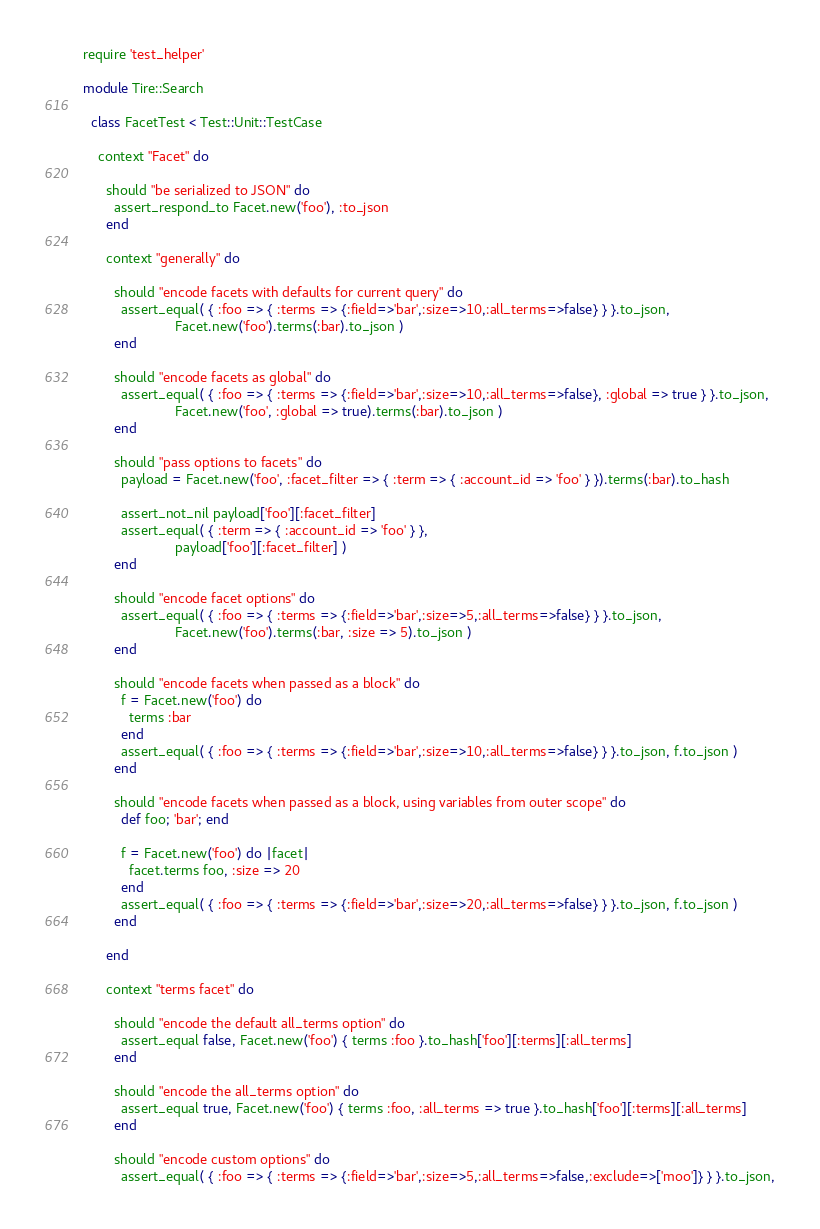<code> <loc_0><loc_0><loc_500><loc_500><_Ruby_>require 'test_helper'

module Tire::Search

  class FacetTest < Test::Unit::TestCase

    context "Facet" do

      should "be serialized to JSON" do
        assert_respond_to Facet.new('foo'), :to_json
      end

      context "generally" do

        should "encode facets with defaults for current query" do
          assert_equal( { :foo => { :terms => {:field=>'bar',:size=>10,:all_terms=>false} } }.to_json,
                        Facet.new('foo').terms(:bar).to_json )
        end

        should "encode facets as global" do
          assert_equal( { :foo => { :terms => {:field=>'bar',:size=>10,:all_terms=>false}, :global => true } }.to_json,
                        Facet.new('foo', :global => true).terms(:bar).to_json )
        end

        should "pass options to facets" do
          payload = Facet.new('foo', :facet_filter => { :term => { :account_id => 'foo' } }).terms(:bar).to_hash

          assert_not_nil payload['foo'][:facet_filter]
          assert_equal( { :term => { :account_id => 'foo' } },
                        payload['foo'][:facet_filter] )
        end

        should "encode facet options" do
          assert_equal( { :foo => { :terms => {:field=>'bar',:size=>5,:all_terms=>false} } }.to_json,
                        Facet.new('foo').terms(:bar, :size => 5).to_json )
        end

        should "encode facets when passed as a block" do
          f = Facet.new('foo') do
            terms :bar
          end
          assert_equal( { :foo => { :terms => {:field=>'bar',:size=>10,:all_terms=>false} } }.to_json, f.to_json )
        end

        should "encode facets when passed as a block, using variables from outer scope" do
          def foo; 'bar'; end

          f = Facet.new('foo') do |facet|
            facet.terms foo, :size => 20
          end
          assert_equal( { :foo => { :terms => {:field=>'bar',:size=>20,:all_terms=>false} } }.to_json, f.to_json )
        end

      end

      context "terms facet" do

        should "encode the default all_terms option" do
          assert_equal false, Facet.new('foo') { terms :foo }.to_hash['foo'][:terms][:all_terms]
        end

        should "encode the all_terms option" do
          assert_equal true, Facet.new('foo') { terms :foo, :all_terms => true }.to_hash['foo'][:terms][:all_terms]
        end

        should "encode custom options" do
          assert_equal( { :foo => { :terms => {:field=>'bar',:size=>5,:all_terms=>false,:exclude=>['moo']} } }.to_json,</code> 